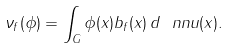Convert formula to latex. <formula><loc_0><loc_0><loc_500><loc_500>\nu _ { f } ( \phi ) = \int _ { G } \phi ( x ) b _ { f } ( x ) \, d \ n n u ( x ) .</formula> 